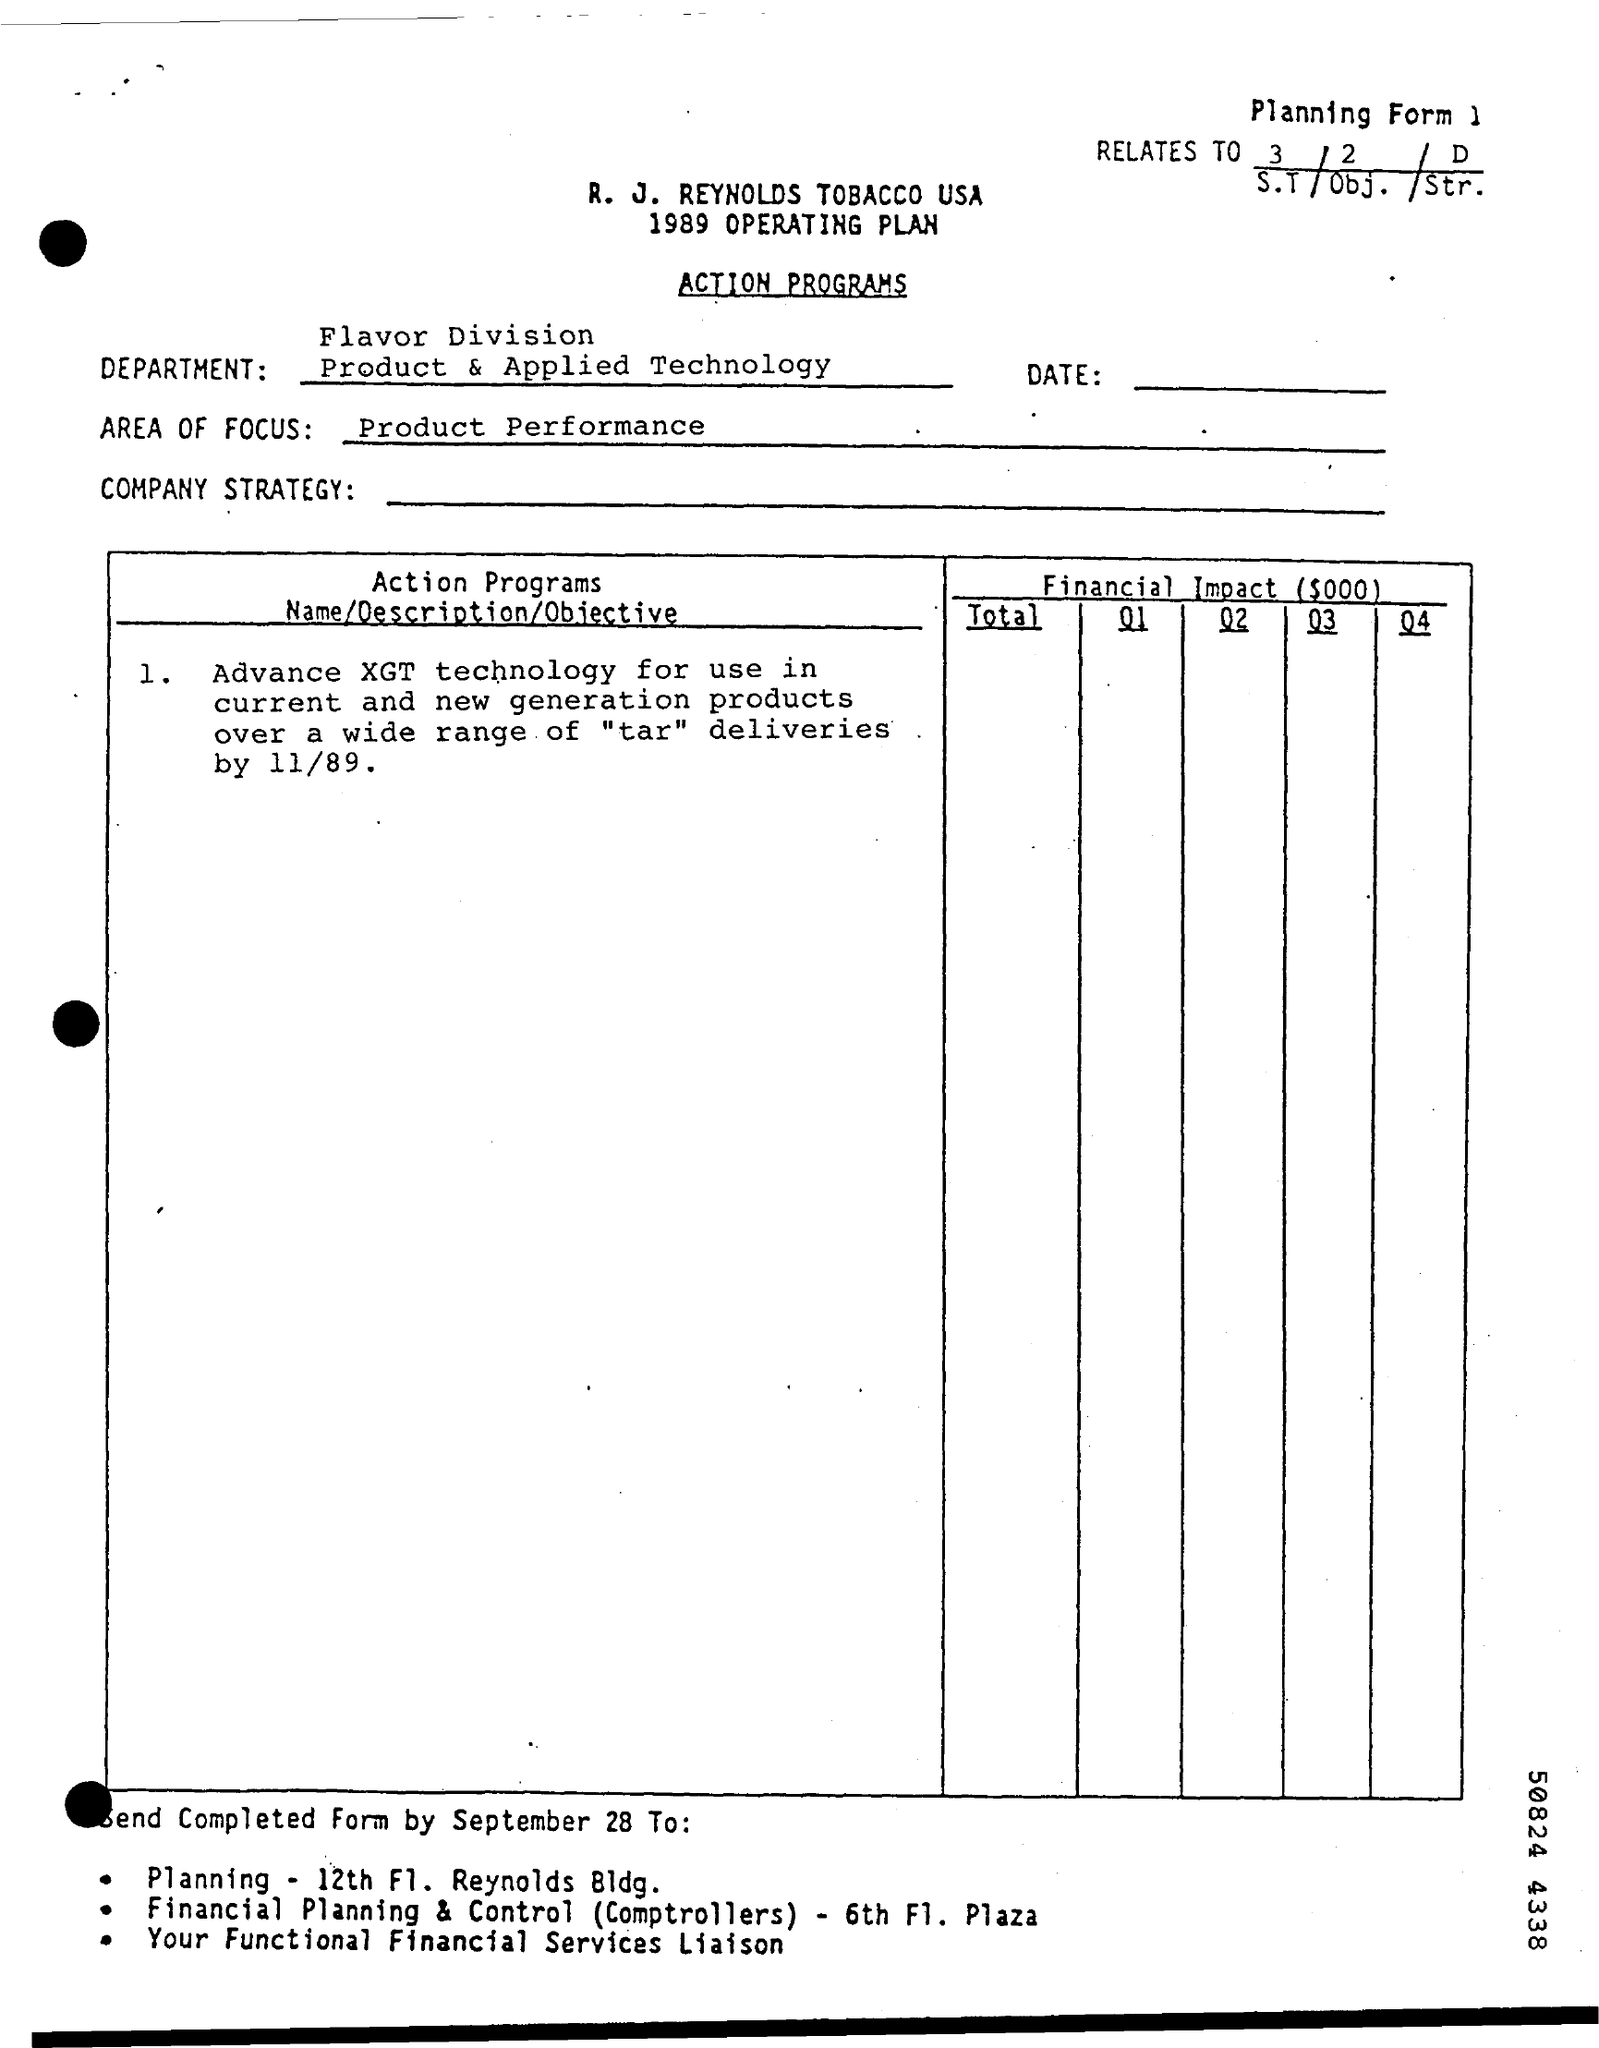Draw attention to some important aspects in this diagram. The areas of focus for product performance are [specifically outlined and defined]. 